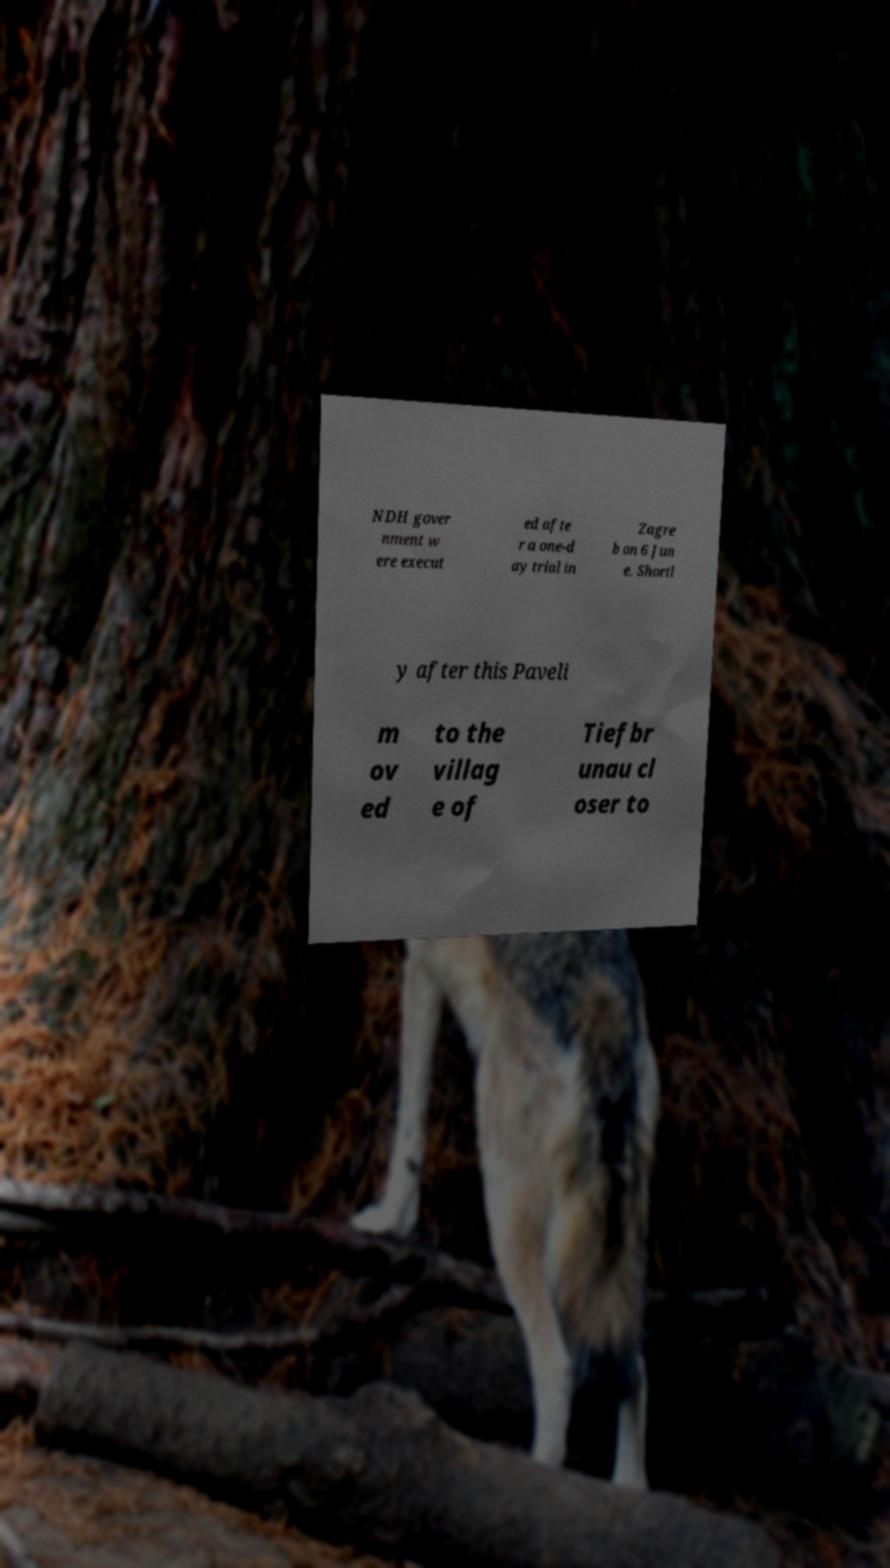Could you assist in decoding the text presented in this image and type it out clearly? NDH gover nment w ere execut ed afte r a one-d ay trial in Zagre b on 6 Jun e. Shortl y after this Paveli m ov ed to the villag e of Tiefbr unau cl oser to 